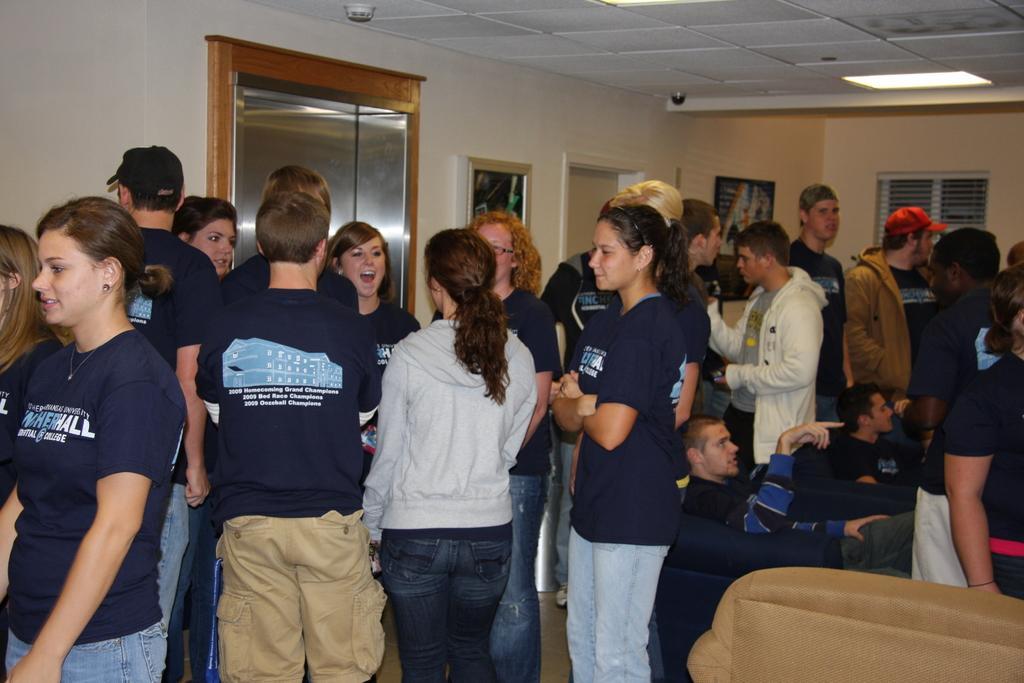Can you describe this image briefly? In this image, I can see groups of people standing and two persons sitting on the chairs. In the background, there are doors, two photo frames attached to the wall and a window. At the top of the image, I can see a ceiling light and two objects are attached to the ceiling. 